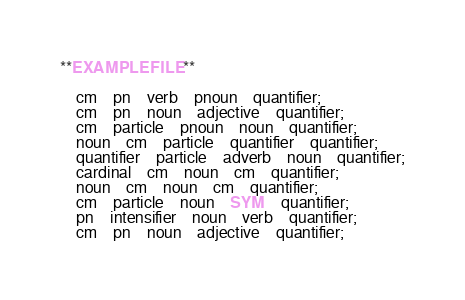<code> <loc_0><loc_0><loc_500><loc_500><_Elixir_>**EXAMPLE FILE**

	cm	pn	verb	pnoun	quantifier;
	cm	pn	noun	adjective	quantifier;
	cm	particle	pnoun	noun	quantifier;
	noun	cm	particle	quantifier	quantifier;
	quantifier	particle	adverb	noun	quantifier;
	cardinal	cm	noun	cm	quantifier;
	noun	cm	noun	cm	quantifier;
	cm	particle	noun	SYM	quantifier;
	pn	intensifier	noun	verb	quantifier;
	cm	pn	noun	adjective	quantifier;
</code> 